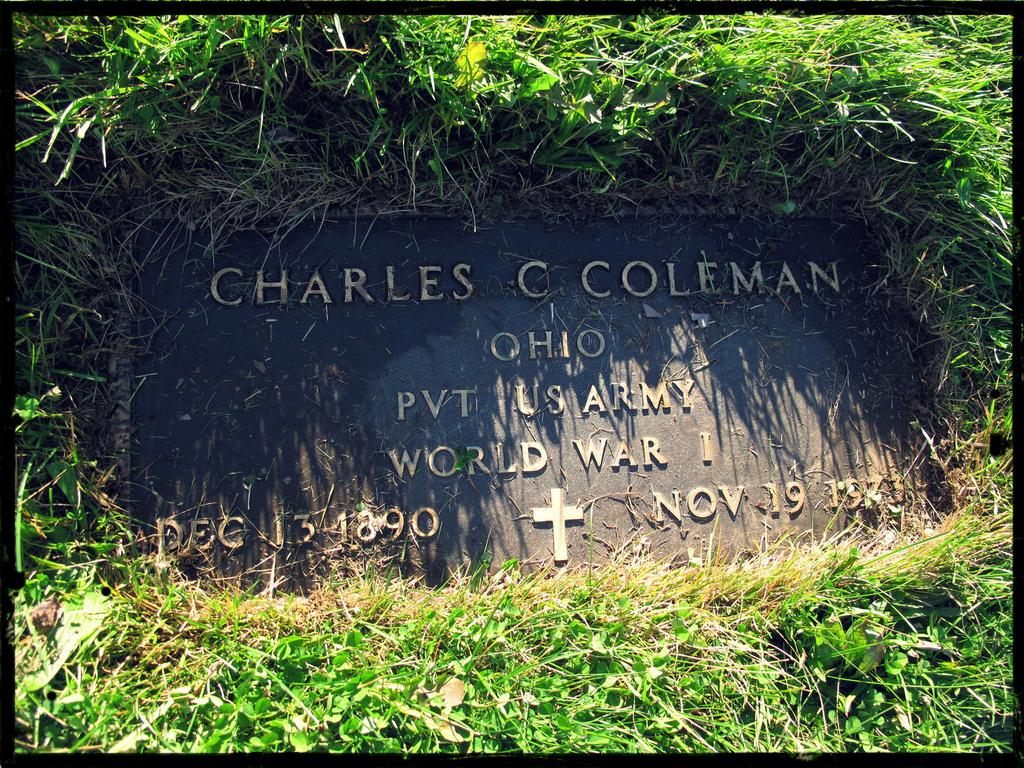What is the main object in the image? There is a board in the image. What type of environment is the board located in? The board is surrounded by grass. Can you describe the behavior of the toad on the board in the image? There is no toad present in the image, so we cannot describe its behavior. 